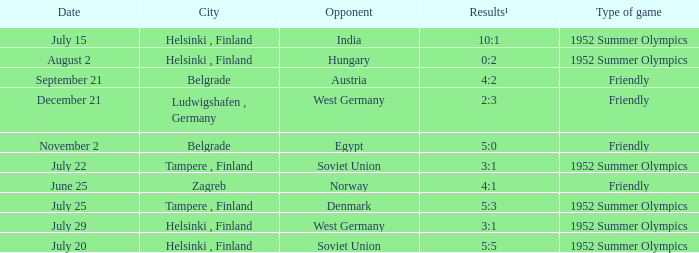What Type of game has a Results¹ of 10:1? 1952 Summer Olympics. 